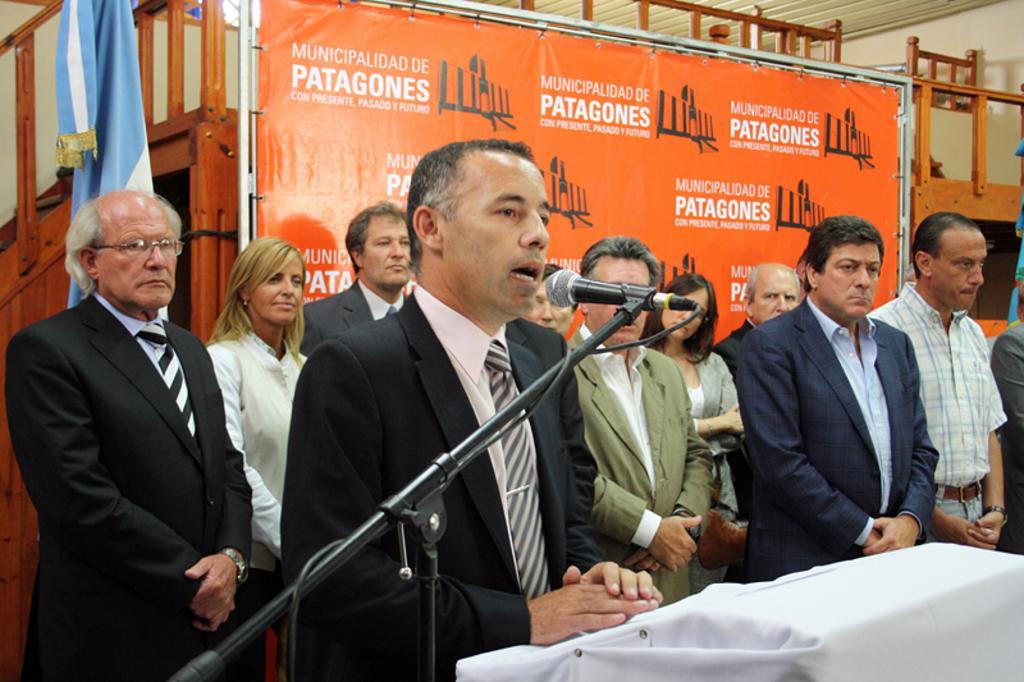In one or two sentences, can you explain what this image depicts? In this image, we can see people standing and wearing coats and there is a mic stand and we can see a table. In the background, there is a board, a cloth and we can see stands. At the top, there is a roof and there is a wall. 